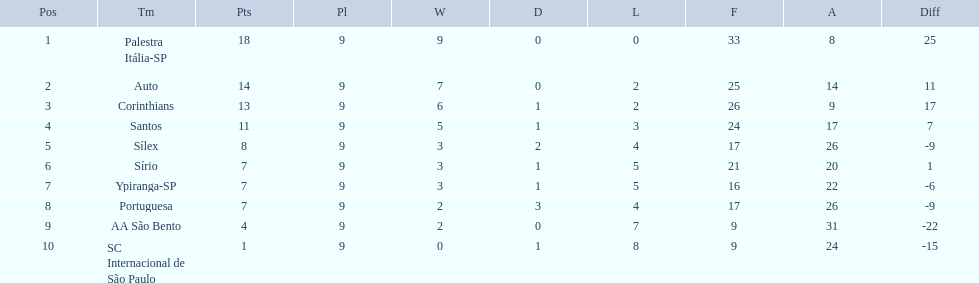Can you give me this table as a dict? {'header': ['Pos', 'Tm', 'Pts', 'Pl', 'W', 'D', 'L', 'F', 'A', 'Diff'], 'rows': [['1', 'Palestra Itália-SP', '18', '9', '9', '0', '0', '33', '8', '25'], ['2', 'Auto', '14', '9', '7', '0', '2', '25', '14', '11'], ['3', 'Corinthians', '13', '9', '6', '1', '2', '26', '9', '17'], ['4', 'Santos', '11', '9', '5', '1', '3', '24', '17', '7'], ['5', 'Sílex', '8', '9', '3', '2', '4', '17', '26', '-9'], ['6', 'Sírio', '7', '9', '3', '1', '5', '21', '20', '1'], ['7', 'Ypiranga-SP', '7', '9', '3', '1', '5', '16', '22', '-6'], ['8', 'Portuguesa', '7', '9', '2', '3', '4', '17', '26', '-9'], ['9', 'AA São Bento', '4', '9', '2', '0', '7', '9', '31', '-22'], ['10', 'SC Internacional de São Paulo', '1', '9', '0', '1', '8', '9', '24', '-15']]} What were the top three amounts of games won for 1926 in brazilian football season? 9, 7, 6. What were the top amount of games won for 1926 in brazilian football season? 9. What team won the top amount of games Palestra Itália-SP. 